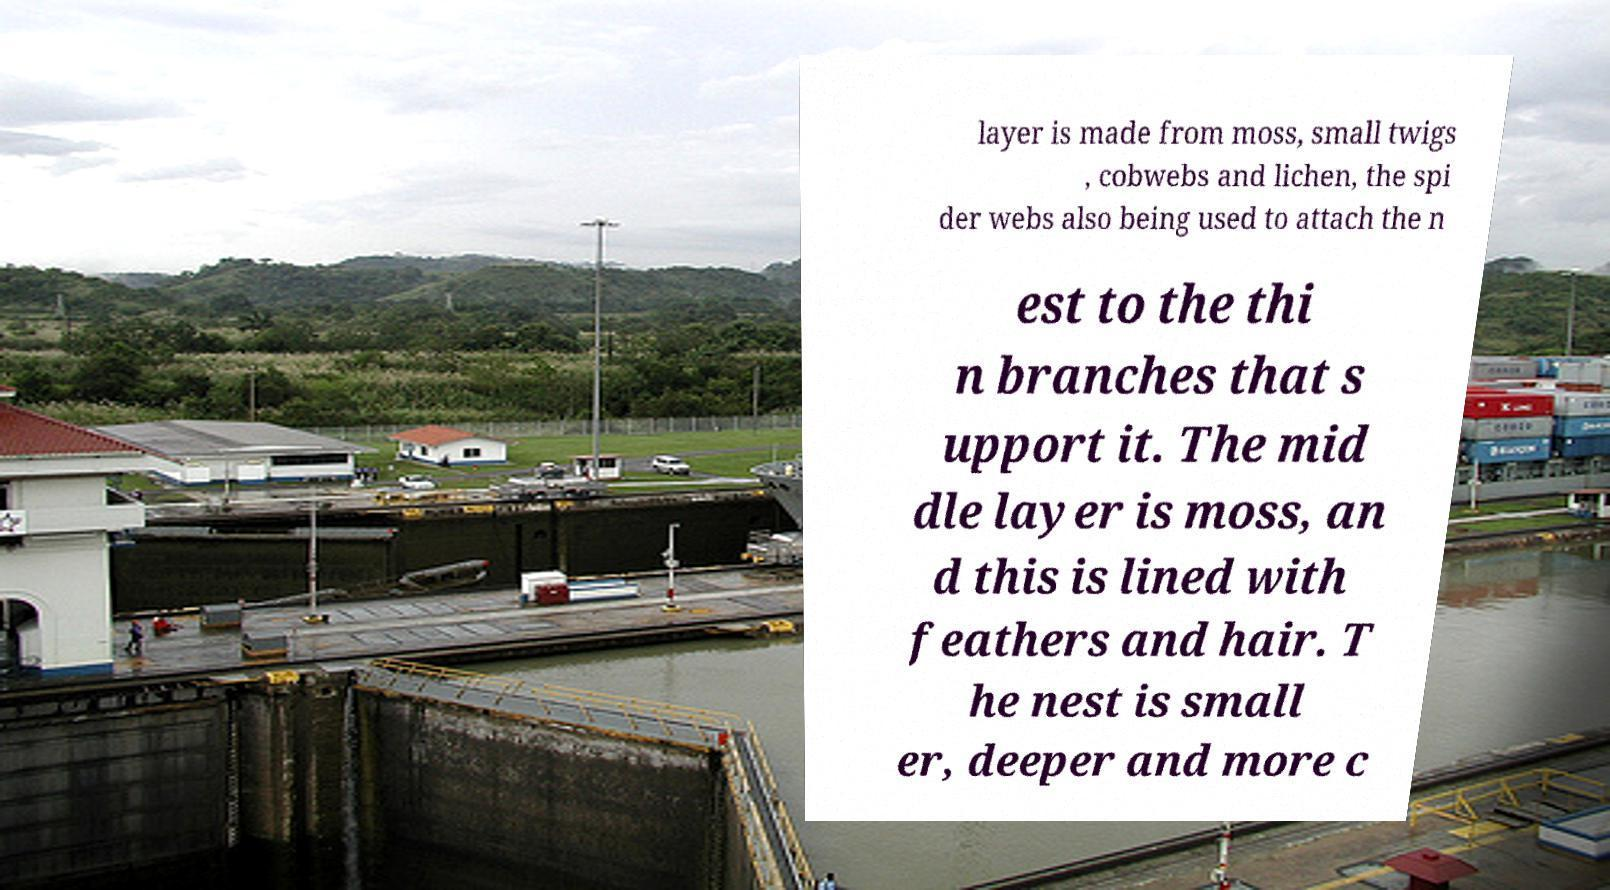Can you accurately transcribe the text from the provided image for me? layer is made from moss, small twigs , cobwebs and lichen, the spi der webs also being used to attach the n est to the thi n branches that s upport it. The mid dle layer is moss, an d this is lined with feathers and hair. T he nest is small er, deeper and more c 